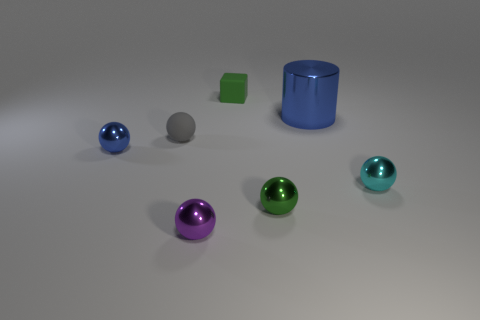Are there any other things of the same color as the matte ball?
Offer a very short reply. No. What shape is the purple object that is the same size as the blue metallic sphere?
Ensure brevity in your answer.  Sphere. Is there a small ball of the same color as the small rubber cube?
Ensure brevity in your answer.  Yes. Is the number of metallic objects behind the small blue metallic ball the same as the number of yellow shiny cubes?
Ensure brevity in your answer.  No. What is the size of the sphere that is to the left of the big cylinder and right of the small green cube?
Offer a terse response. Small. There is a big cylinder that is made of the same material as the tiny cyan thing; what color is it?
Keep it short and to the point. Blue. How many spheres are made of the same material as the large cylinder?
Give a very brief answer. 4. Is the number of tiny green shiny spheres that are in front of the green sphere the same as the number of things left of the tiny blue shiny ball?
Your answer should be compact. Yes. There is a gray thing; is it the same shape as the thing that is behind the big metallic cylinder?
Give a very brief answer. No. There is a small object that is the same color as the large object; what is it made of?
Ensure brevity in your answer.  Metal. 